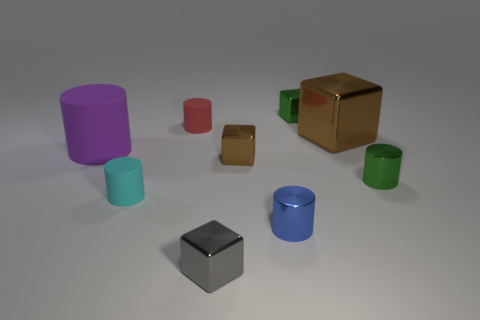Subtract all small metallic cylinders. How many cylinders are left? 3 Add 1 matte cylinders. How many objects exist? 10 Subtract all gray blocks. How many blocks are left? 3 Subtract 3 cylinders. How many cylinders are left? 2 Add 9 small purple shiny balls. How many small purple shiny balls exist? 9 Subtract 0 yellow blocks. How many objects are left? 9 Subtract all blocks. How many objects are left? 5 Subtract all yellow cubes. Subtract all gray spheres. How many cubes are left? 4 Subtract all purple cubes. How many blue cylinders are left? 1 Subtract all small gray things. Subtract all large cubes. How many objects are left? 7 